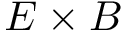Convert formula to latex. <formula><loc_0><loc_0><loc_500><loc_500>E \times B</formula> 